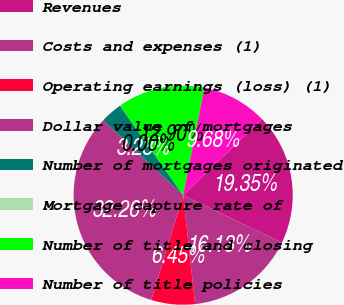Convert chart to OTSL. <chart><loc_0><loc_0><loc_500><loc_500><pie_chart><fcel>Revenues<fcel>Costs and expenses (1)<fcel>Operating earnings (loss) (1)<fcel>Dollar value of mortgages<fcel>Number of mortgages originated<fcel>Mortgage capture rate of<fcel>Number of title and closing<fcel>Number of title policies<nl><fcel>19.35%<fcel>16.13%<fcel>6.45%<fcel>32.26%<fcel>3.23%<fcel>0.0%<fcel>12.9%<fcel>9.68%<nl></chart> 